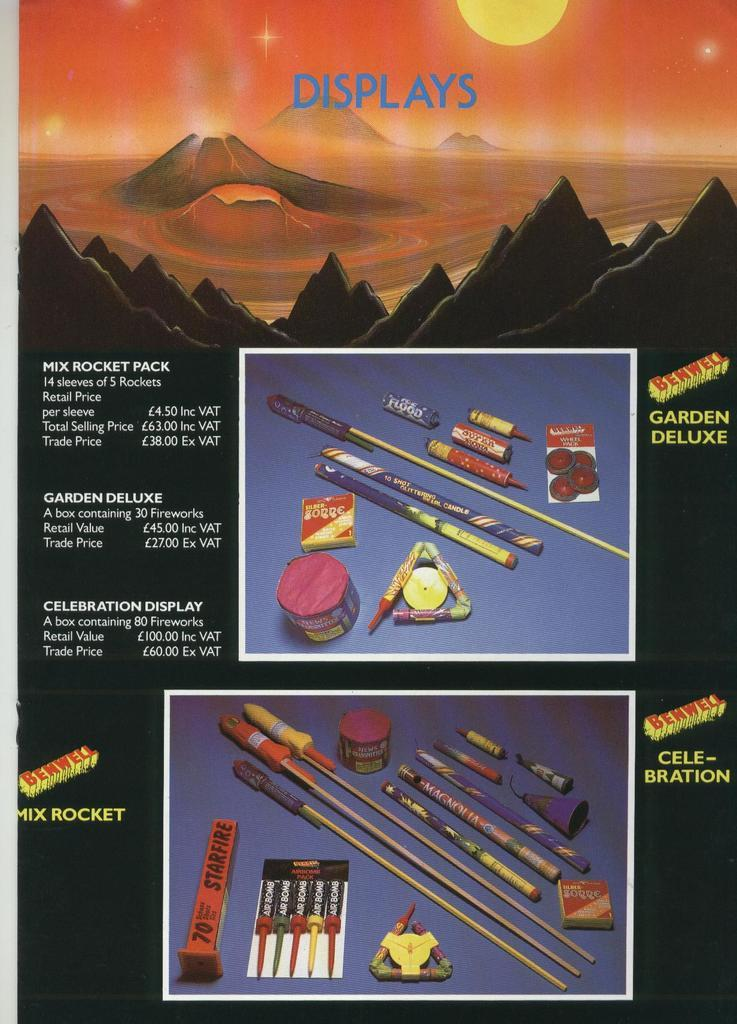What is the main subject of the poster in the image? The poster contains images of different types of crackers. Are there any additional details about the crackers on the poster? Yes, the prices of the crackers are mentioned beside their respective images on the poster. What type of breakfast is being served in the image? There is no breakfast visible in the image; it only contains a poster with images of crackers and their prices. How many trucks are shown carrying the crackers in the image? There are no trucks present in the image; it only contains a poster with images of crackers and their prices. 